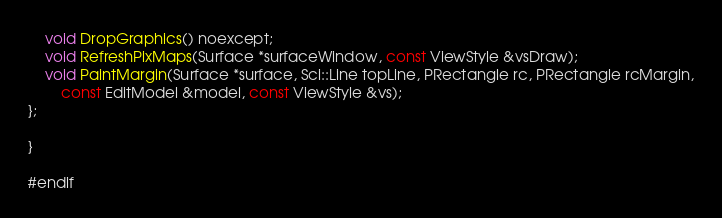<code> <loc_0><loc_0><loc_500><loc_500><_C_>
	void DropGraphics() noexcept;
	void RefreshPixMaps(Surface *surfaceWindow, const ViewStyle &vsDraw);
	void PaintMargin(Surface *surface, Sci::Line topLine, PRectangle rc, PRectangle rcMargin,
		const EditModel &model, const ViewStyle &vs);
};

}

#endif
</code> 